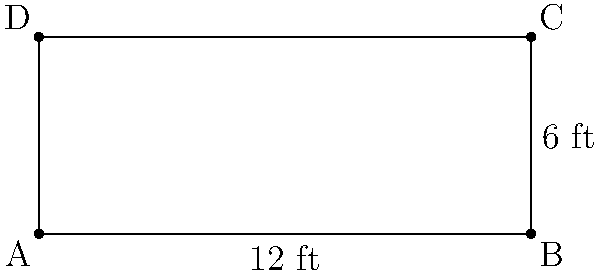As a food critic, you're reviewing a new restaurant's kitchen. The chef proudly shows you their custom-made rectangular kitchen counter. If the counter measures 12 feet in length and 6 feet in width, what is its perimeter? Express your answer in feet. Let's approach this step-by-step:

1) First, recall the formula for the perimeter of a rectangle:
   $$ \text{Perimeter} = 2 \times (\text{length} + \text{width}) $$

2) We're given:
   - Length = 12 feet
   - Width = 6 feet

3) Let's substitute these values into our formula:
   $$ \text{Perimeter} = 2 \times (12 \text{ ft} + 6 \text{ ft}) $$

4) Now, let's solve the equation:
   $$ \text{Perimeter} = 2 \times (18 \text{ ft}) $$
   $$ \text{Perimeter} = 36 \text{ ft} $$

Therefore, the perimeter of the kitchen counter is 36 feet.
Answer: 36 ft 